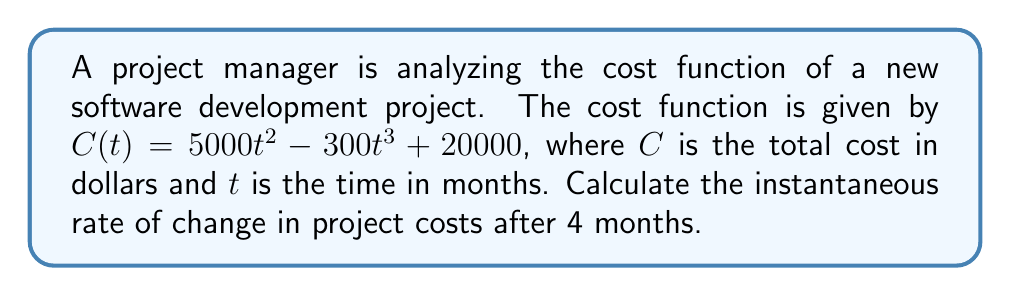Teach me how to tackle this problem. To find the instantaneous rate of change in project costs after 4 months, we need to follow these steps:

1. Recognize that the instantaneous rate of change is given by the derivative of the cost function $C(t)$ at $t = 4$.

2. Find the derivative of $C(t)$:
   $$\frac{d}{dt}C(t) = \frac{d}{dt}(5000t^2 - 300t^3 + 20000)$$
   $$C'(t) = 10000t - 900t^2$$

3. Evaluate the derivative at $t = 4$:
   $$C'(4) = 10000(4) - 900(4^2)$$
   $$C'(4) = 40000 - 14400$$
   $$C'(4) = 25600$$

The positive value indicates that the project costs are increasing at this point in time.
Answer: $25600 per month 